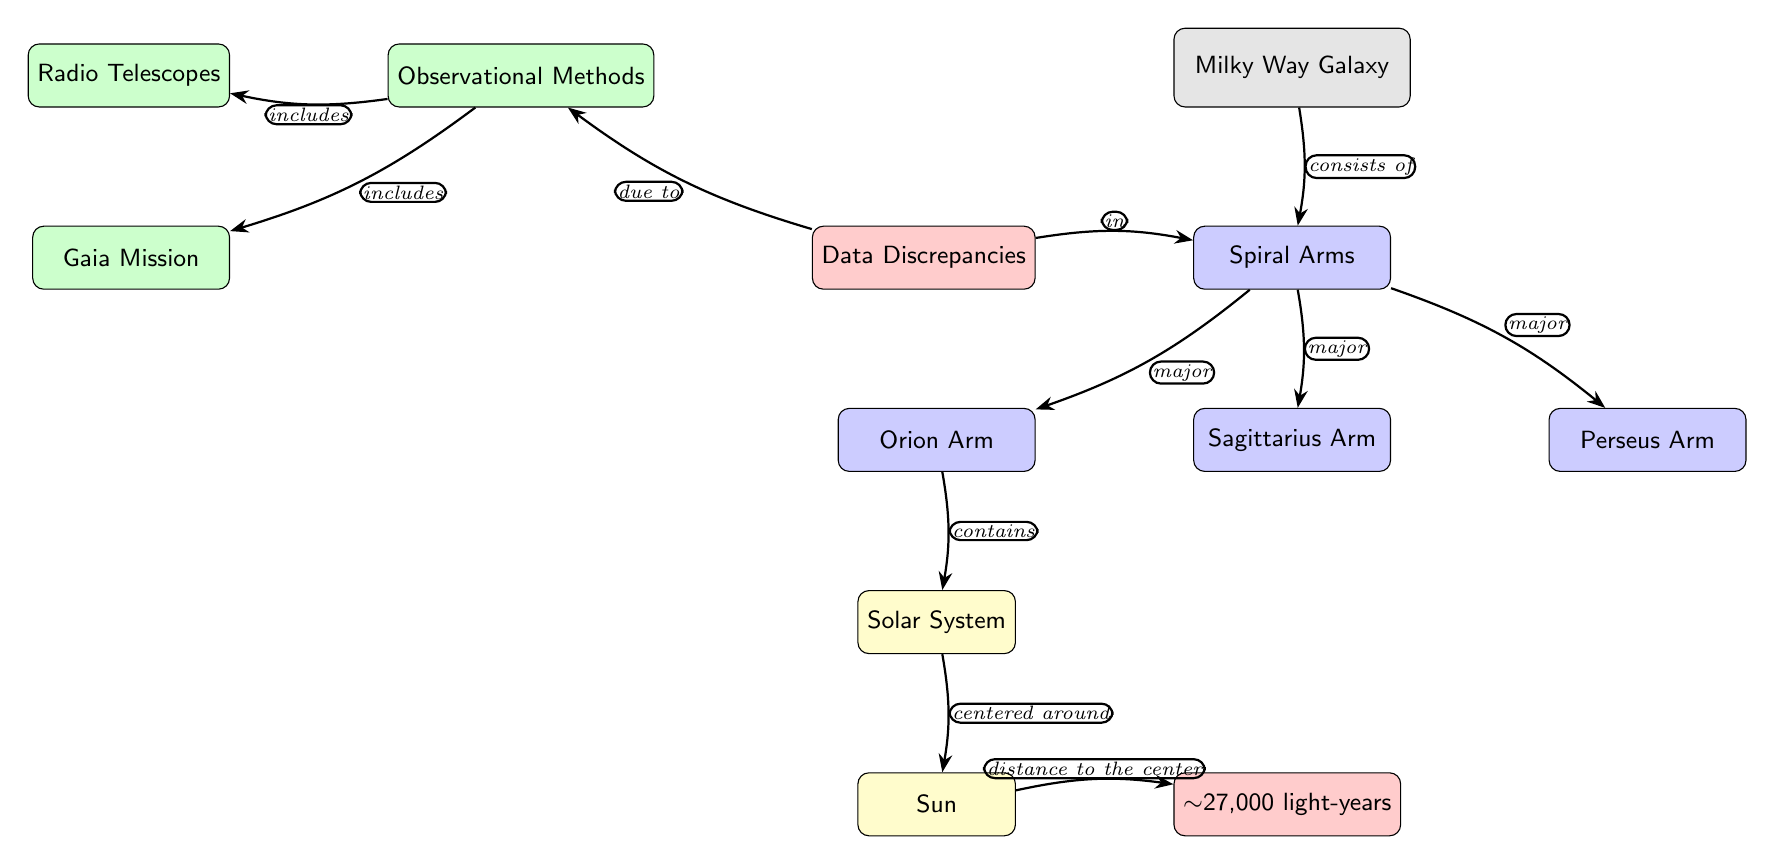What galaxy is illustrated in the diagram? The diagram explicitly labels the structure as the "Milky Way Galaxy," indicating that this is the galaxy being depicted.
Answer: Milky Way Galaxy How many major spiral arms are shown in the diagram? The diagram displays three labeled major spiral arms: Orion Arm, Sagittarius Arm, and Perseus Arm, which can be counted directly from the nodes.
Answer: 3 What is the distance from the solar system to the center of the Milky Way? The diagram indicates this distance as approximately 27,000 light-years, as shown next to the sun node.
Answer: 27,000 light-years What are the two observational methods listed in the diagram? The diagram specifically includes "Radio Telescopes" and "Gaia Mission" as methods used for observations of the galaxy, listed under the respective node.
Answer: Radio Telescopes, Gaia Mission Which arm contains the solar system? The diagram explicitly connects the "Orion Arm" to the "Solar System," making it clear that the solar system is contained within this arm.
Answer: Orion Arm What does the edge between discrepancies and observational methods represent? The edge is labeled "due to," revealing that the discrepancies in data are a result of the observational methods employed to understand the galaxy.
Answer: due to What color represents the solar system in the diagram? The solar system is represented in yellow according to the node style defined within the diagram, making it visually distinct.
Answer: Yellow Which node directly connects to the sun? The "Solar System" node is connected directly to the "Sun" node, as indicated in the diagram.
Answer: Solar System What discrepancy is highlighted in the diagram? The diagram points to "Data Discrepancies" within the spiral arms of the Milky Way, which addresses inconsistencies in our knowledge about the galaxy's structure.
Answer: Data Discrepancies 